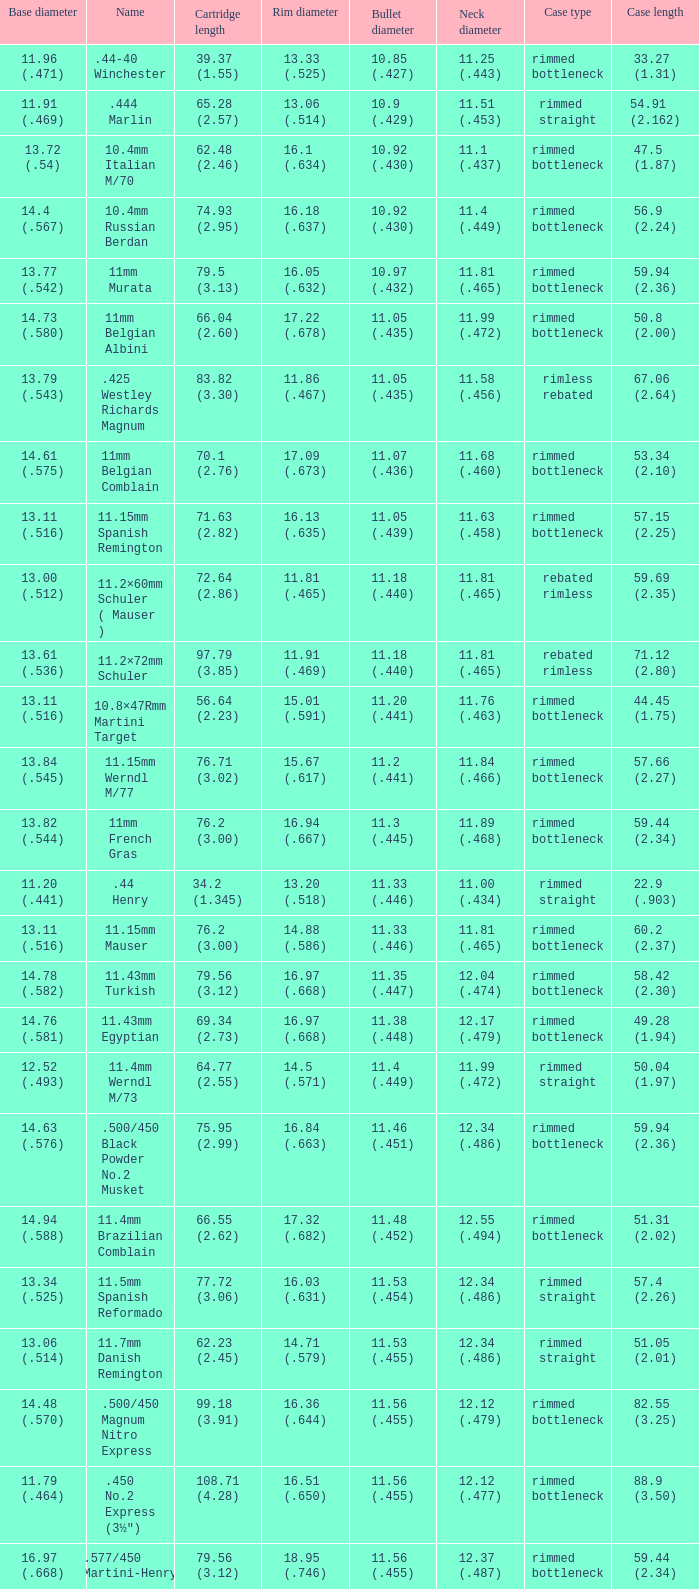Which Rim diameter has a Neck diameter of 11.84 (.466)? 15.67 (.617). 